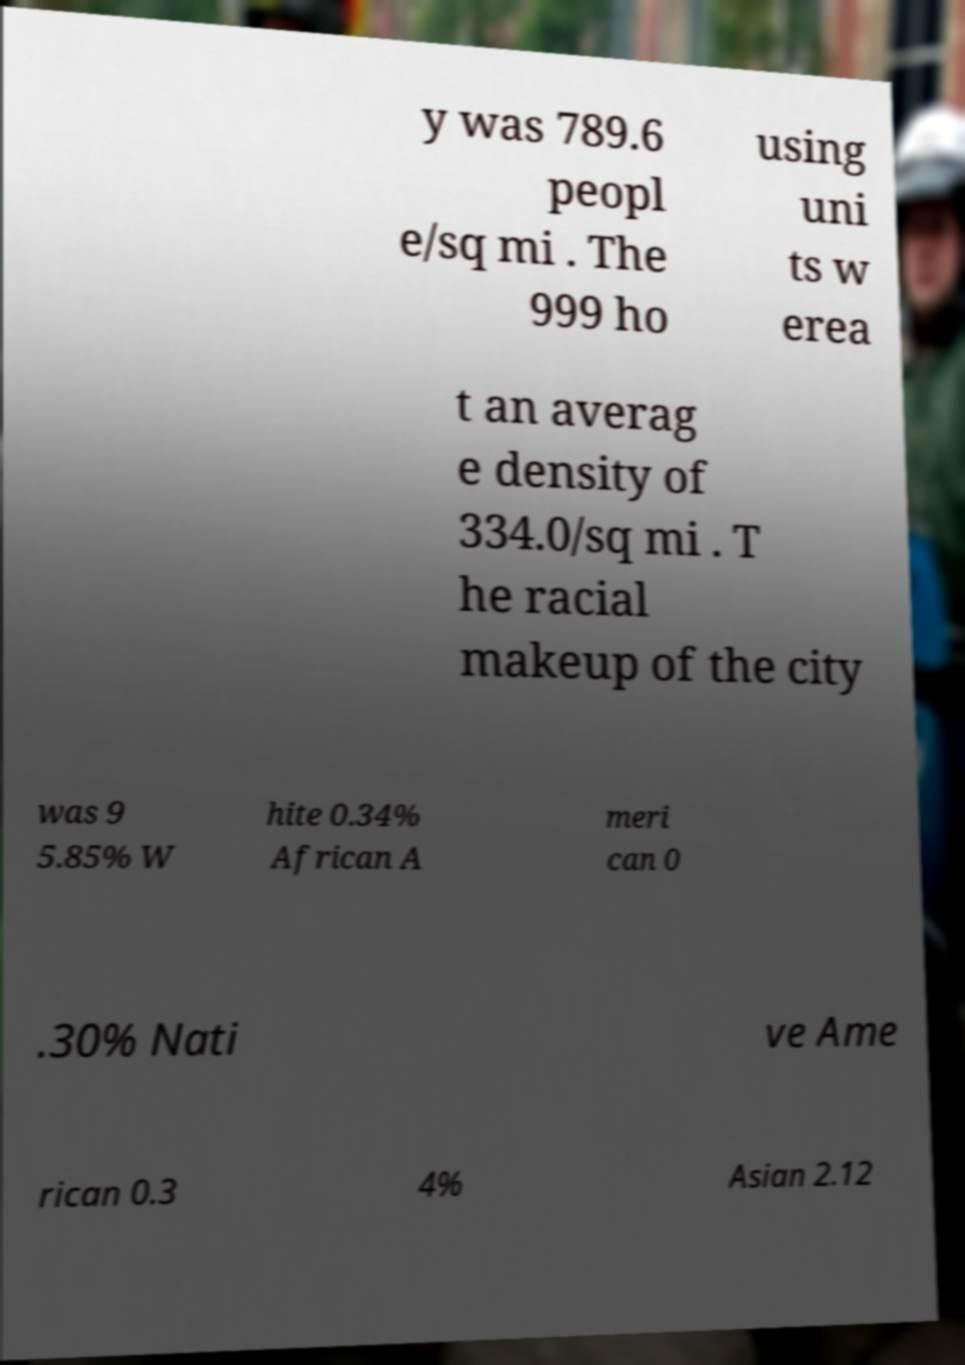I need the written content from this picture converted into text. Can you do that? y was 789.6 peopl e/sq mi . The 999 ho using uni ts w erea t an averag e density of 334.0/sq mi . T he racial makeup of the city was 9 5.85% W hite 0.34% African A meri can 0 .30% Nati ve Ame rican 0.3 4% Asian 2.12 